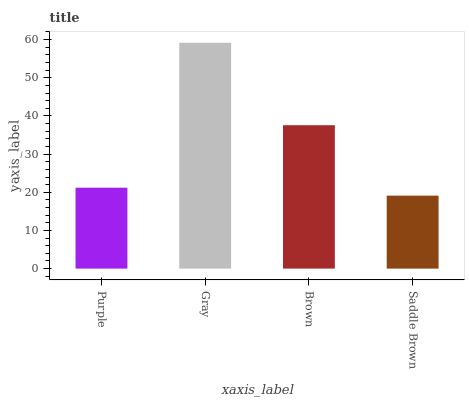Is Brown the minimum?
Answer yes or no. No. Is Brown the maximum?
Answer yes or no. No. Is Gray greater than Brown?
Answer yes or no. Yes. Is Brown less than Gray?
Answer yes or no. Yes. Is Brown greater than Gray?
Answer yes or no. No. Is Gray less than Brown?
Answer yes or no. No. Is Brown the high median?
Answer yes or no. Yes. Is Purple the low median?
Answer yes or no. Yes. Is Gray the high median?
Answer yes or no. No. Is Saddle Brown the low median?
Answer yes or no. No. 